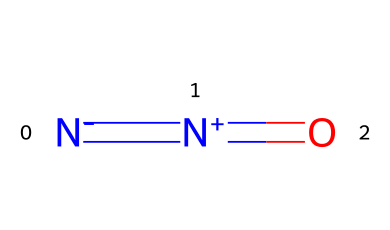What is the molecular formula of this compound? By analyzing the SMILES representation N#N=O, we can identify the components: there are two nitrogen atoms (N) and one oxygen atom (O). Thus, the molecular formula can be derived directly from this information.
Answer: N2O How many atoms are present in this molecule? The SMILES representation includes two nitrogen atoms and one oxygen atom, totaling three atoms combined.
Answer: 3 What type of bonds are present in nitrous oxide? In the SMILES notation, N#N indicates a triple bond between the two nitrogen atoms, and N=O indicates a double bond between the nitrogen and oxygen atoms. Therefore, this molecule has a triple bond and a double bond.
Answer: triple bond, double bond What is the geometry around the nitrogen atom in nitrous oxide? By examining the molecular structure of nitrous oxide, particularly focusing on the bonding angles influenced by the triple and double bonds, we can deduce that the nitrogen atoms exhibit a linear geometry.
Answer: linear How does nitrous oxide behave as an anesthetic? The presence of the nitrogen and oxygen atoms in this structure allows nitrous oxide to interact with the nervous system effectively, leading to its anesthetic properties primarily through its action on NMDA receptors and opioid receptors.
Answer: NMDA and opioid receptors Is nitrous oxide a greenhouse gas? Yes, nitrous oxide has been identified as a greenhouse gas due to its ability to trap heat in the atmosphere, a characteristic attributed to its structure and molecular interactions.
Answer: Yes 